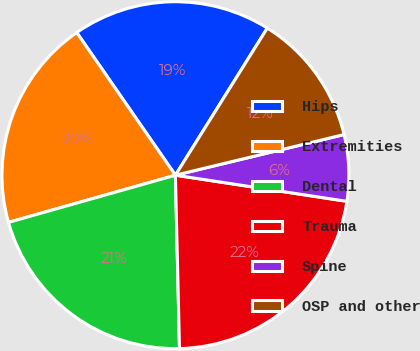Convert chart. <chart><loc_0><loc_0><loc_500><loc_500><pie_chart><fcel>Hips<fcel>Extremities<fcel>Dental<fcel>Trauma<fcel>Spine<fcel>OSP and other<nl><fcel>18.52%<fcel>19.75%<fcel>20.99%<fcel>22.22%<fcel>6.17%<fcel>12.35%<nl></chart> 